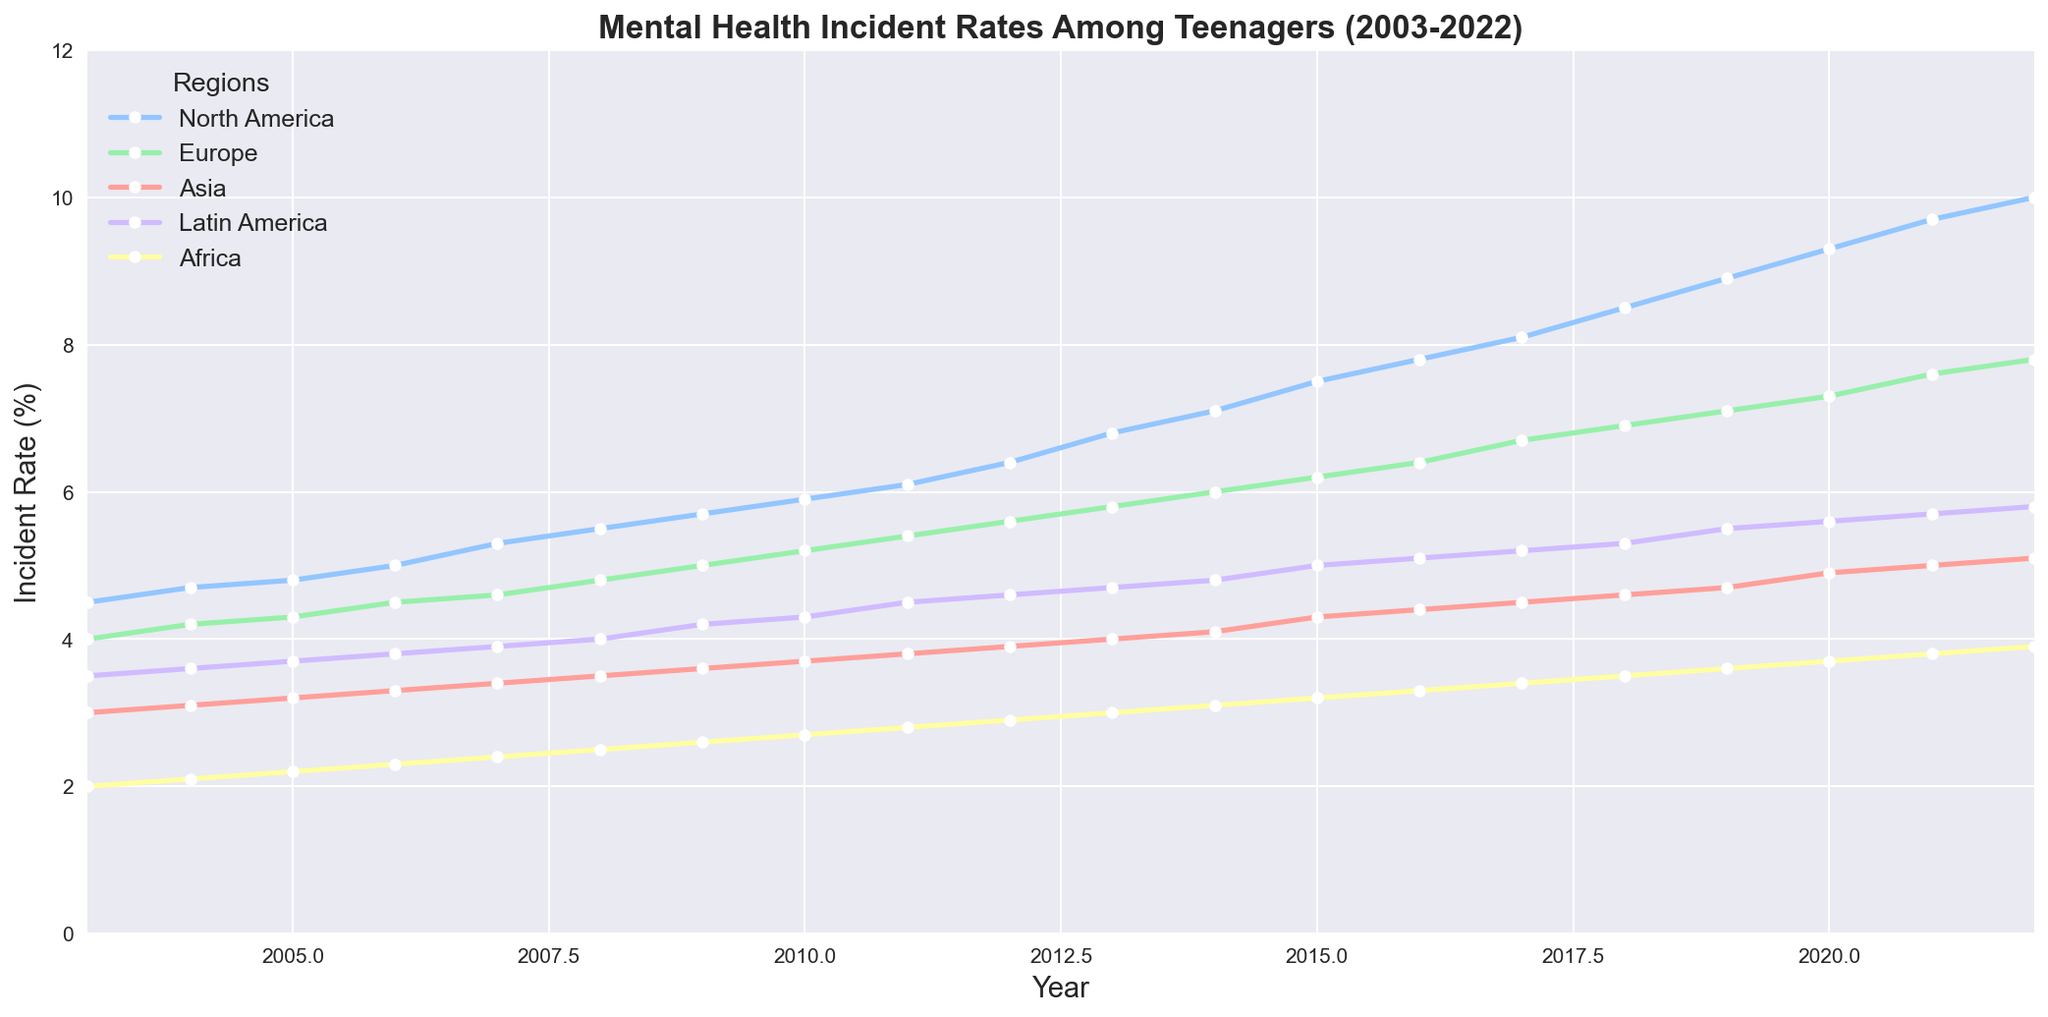What trend do we observe in North America's mental health incident rates from 2003 to 2022? By examining the line for North America, we can see a clear upward trend in the incident rates. Starting from 4.5% in 2003, the rate continuously increases each year, reaching 10.0% in 2022.
Answer: Upward trend Which region had the highest mental health incident rate in 2022? By identifying the highest data point in 2022 across all regions, we observe that North America had the highest incident rate at 10.0%.
Answer: North America Between 2010 and 2015, which region showed the largest increase in mental health incident rates? Compare the difference in rates from 2010 to 2015 for each region: North America (1.6%), Europe (1.0%), Asia (0.6%), Latin America (0.7%), Africa (0.5%). North America shows the largest increase.
Answer: North America By how much did Africa's mental health incident rates increase from 2003 to 2022? Subtract the 2003 rate from the 2022 rate for Africa: 3.9% - 2.0% = 1.9%.
Answer: 1.9% In 2015, how did Asia's mental health incident rate compare to Latin America's rate? Look at the rates for Asia and Latin America in 2015: Asia (4.3%) and Latin America (5.0%). Asia's rate was 0.7% lower than Latin America's.
Answer: 0.7% lower What is the overall trend in mental health incident rates for Latin America from 2003 to 2022? By tracing the line for Latin America from 2003 to 2022, it is evident that there is a consistent increasing trend, rising from 3.5% to 5.8%.
Answer: Increasing trend Which region experienced the smallest growth in mental health incident rates between 2003 and 2022? Calculate the total increase for each region: North America (5.5%), Europe (3.8%), Asia (2.1%), Latin America (2.3%), Africa (1.9%). Africa experienced the smallest growth.
Answer: Africa In which year did Europe surpass an incident rate of 6.0% for the first time? Examine the data points for Europe and identify the year when the rate first exceeds 6.0%. This occurs in 2014 when the incident rate reached 6.0%.
Answer: 2014 Compare North America's and Latin America's incident rates in 2010. Which region had a higher rate, and by how much? North America's rate in 2010 was 5.9%, while Latin America's was 4.3%. North America had an incident rate that was 1.6% higher than Latin America's.
Answer: North America, 1.6% higher 